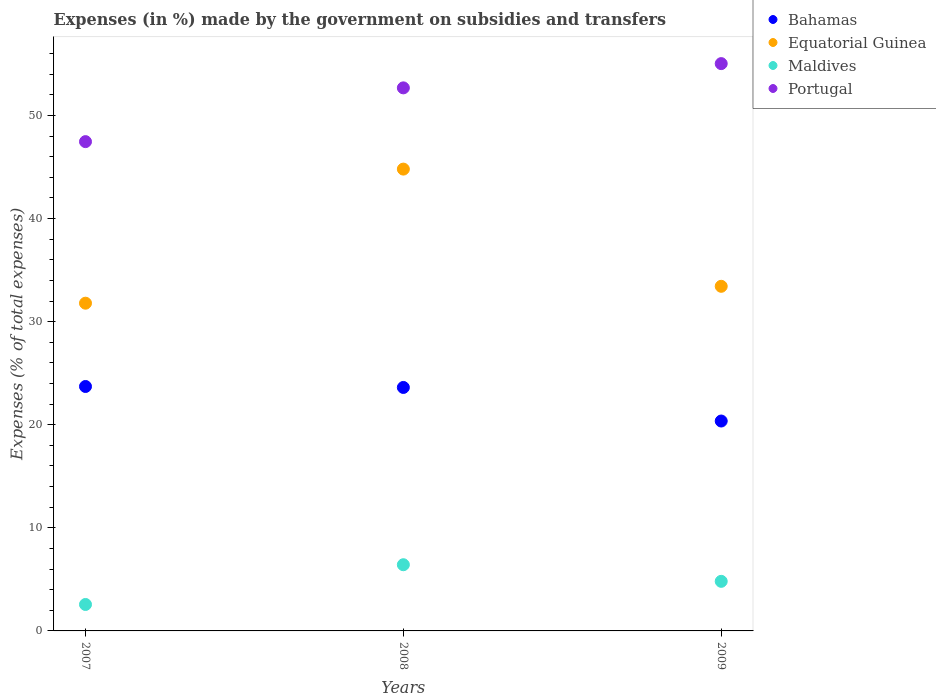What is the percentage of expenses made by the government on subsidies and transfers in Portugal in 2007?
Your answer should be compact. 47.46. Across all years, what is the maximum percentage of expenses made by the government on subsidies and transfers in Equatorial Guinea?
Offer a terse response. 44.8. Across all years, what is the minimum percentage of expenses made by the government on subsidies and transfers in Equatorial Guinea?
Your response must be concise. 31.79. In which year was the percentage of expenses made by the government on subsidies and transfers in Portugal minimum?
Make the answer very short. 2007. What is the total percentage of expenses made by the government on subsidies and transfers in Portugal in the graph?
Provide a succinct answer. 155.17. What is the difference between the percentage of expenses made by the government on subsidies and transfers in Bahamas in 2007 and that in 2009?
Your answer should be very brief. 3.35. What is the difference between the percentage of expenses made by the government on subsidies and transfers in Bahamas in 2008 and the percentage of expenses made by the government on subsidies and transfers in Equatorial Guinea in 2009?
Make the answer very short. -9.81. What is the average percentage of expenses made by the government on subsidies and transfers in Bahamas per year?
Offer a very short reply. 22.56. In the year 2007, what is the difference between the percentage of expenses made by the government on subsidies and transfers in Portugal and percentage of expenses made by the government on subsidies and transfers in Equatorial Guinea?
Give a very brief answer. 15.67. In how many years, is the percentage of expenses made by the government on subsidies and transfers in Maldives greater than 6 %?
Keep it short and to the point. 1. What is the ratio of the percentage of expenses made by the government on subsidies and transfers in Equatorial Guinea in 2007 to that in 2008?
Your response must be concise. 0.71. Is the percentage of expenses made by the government on subsidies and transfers in Bahamas in 2007 less than that in 2009?
Provide a succinct answer. No. What is the difference between the highest and the second highest percentage of expenses made by the government on subsidies and transfers in Maldives?
Make the answer very short. 1.61. What is the difference between the highest and the lowest percentage of expenses made by the government on subsidies and transfers in Equatorial Guinea?
Give a very brief answer. 13.01. Is it the case that in every year, the sum of the percentage of expenses made by the government on subsidies and transfers in Equatorial Guinea and percentage of expenses made by the government on subsidies and transfers in Bahamas  is greater than the sum of percentage of expenses made by the government on subsidies and transfers in Maldives and percentage of expenses made by the government on subsidies and transfers in Portugal?
Provide a succinct answer. No. Does the percentage of expenses made by the government on subsidies and transfers in Equatorial Guinea monotonically increase over the years?
Keep it short and to the point. No. Is the percentage of expenses made by the government on subsidies and transfers in Equatorial Guinea strictly less than the percentage of expenses made by the government on subsidies and transfers in Maldives over the years?
Ensure brevity in your answer.  No. How many dotlines are there?
Make the answer very short. 4. What is the difference between two consecutive major ticks on the Y-axis?
Give a very brief answer. 10. Are the values on the major ticks of Y-axis written in scientific E-notation?
Give a very brief answer. No. What is the title of the graph?
Provide a succinct answer. Expenses (in %) made by the government on subsidies and transfers. Does "Congo (Democratic)" appear as one of the legend labels in the graph?
Your answer should be very brief. No. What is the label or title of the Y-axis?
Give a very brief answer. Expenses (% of total expenses). What is the Expenses (% of total expenses) of Bahamas in 2007?
Make the answer very short. 23.71. What is the Expenses (% of total expenses) of Equatorial Guinea in 2007?
Provide a short and direct response. 31.79. What is the Expenses (% of total expenses) in Maldives in 2007?
Provide a short and direct response. 2.57. What is the Expenses (% of total expenses) of Portugal in 2007?
Provide a succinct answer. 47.46. What is the Expenses (% of total expenses) in Bahamas in 2008?
Offer a very short reply. 23.62. What is the Expenses (% of total expenses) in Equatorial Guinea in 2008?
Make the answer very short. 44.8. What is the Expenses (% of total expenses) in Maldives in 2008?
Your answer should be compact. 6.42. What is the Expenses (% of total expenses) of Portugal in 2008?
Your answer should be very brief. 52.68. What is the Expenses (% of total expenses) of Bahamas in 2009?
Your response must be concise. 20.36. What is the Expenses (% of total expenses) in Equatorial Guinea in 2009?
Your response must be concise. 33.43. What is the Expenses (% of total expenses) in Maldives in 2009?
Your answer should be very brief. 4.81. What is the Expenses (% of total expenses) of Portugal in 2009?
Offer a terse response. 55.03. Across all years, what is the maximum Expenses (% of total expenses) of Bahamas?
Make the answer very short. 23.71. Across all years, what is the maximum Expenses (% of total expenses) in Equatorial Guinea?
Offer a very short reply. 44.8. Across all years, what is the maximum Expenses (% of total expenses) in Maldives?
Your response must be concise. 6.42. Across all years, what is the maximum Expenses (% of total expenses) in Portugal?
Offer a terse response. 55.03. Across all years, what is the minimum Expenses (% of total expenses) of Bahamas?
Provide a short and direct response. 20.36. Across all years, what is the minimum Expenses (% of total expenses) in Equatorial Guinea?
Provide a succinct answer. 31.79. Across all years, what is the minimum Expenses (% of total expenses) of Maldives?
Provide a short and direct response. 2.57. Across all years, what is the minimum Expenses (% of total expenses) in Portugal?
Provide a short and direct response. 47.46. What is the total Expenses (% of total expenses) in Bahamas in the graph?
Your response must be concise. 67.69. What is the total Expenses (% of total expenses) in Equatorial Guinea in the graph?
Keep it short and to the point. 110.01. What is the total Expenses (% of total expenses) of Maldives in the graph?
Your answer should be very brief. 13.8. What is the total Expenses (% of total expenses) in Portugal in the graph?
Provide a succinct answer. 155.17. What is the difference between the Expenses (% of total expenses) in Bahamas in 2007 and that in 2008?
Make the answer very short. 0.09. What is the difference between the Expenses (% of total expenses) of Equatorial Guinea in 2007 and that in 2008?
Your answer should be compact. -13.01. What is the difference between the Expenses (% of total expenses) of Maldives in 2007 and that in 2008?
Keep it short and to the point. -3.86. What is the difference between the Expenses (% of total expenses) of Portugal in 2007 and that in 2008?
Keep it short and to the point. -5.22. What is the difference between the Expenses (% of total expenses) of Bahamas in 2007 and that in 2009?
Make the answer very short. 3.35. What is the difference between the Expenses (% of total expenses) in Equatorial Guinea in 2007 and that in 2009?
Offer a terse response. -1.64. What is the difference between the Expenses (% of total expenses) in Maldives in 2007 and that in 2009?
Ensure brevity in your answer.  -2.24. What is the difference between the Expenses (% of total expenses) of Portugal in 2007 and that in 2009?
Offer a terse response. -7.57. What is the difference between the Expenses (% of total expenses) of Bahamas in 2008 and that in 2009?
Provide a succinct answer. 3.26. What is the difference between the Expenses (% of total expenses) in Equatorial Guinea in 2008 and that in 2009?
Ensure brevity in your answer.  11.37. What is the difference between the Expenses (% of total expenses) in Maldives in 2008 and that in 2009?
Your answer should be very brief. 1.61. What is the difference between the Expenses (% of total expenses) in Portugal in 2008 and that in 2009?
Offer a terse response. -2.35. What is the difference between the Expenses (% of total expenses) of Bahamas in 2007 and the Expenses (% of total expenses) of Equatorial Guinea in 2008?
Provide a short and direct response. -21.09. What is the difference between the Expenses (% of total expenses) of Bahamas in 2007 and the Expenses (% of total expenses) of Maldives in 2008?
Your response must be concise. 17.29. What is the difference between the Expenses (% of total expenses) in Bahamas in 2007 and the Expenses (% of total expenses) in Portugal in 2008?
Your answer should be compact. -28.97. What is the difference between the Expenses (% of total expenses) in Equatorial Guinea in 2007 and the Expenses (% of total expenses) in Maldives in 2008?
Keep it short and to the point. 25.37. What is the difference between the Expenses (% of total expenses) in Equatorial Guinea in 2007 and the Expenses (% of total expenses) in Portugal in 2008?
Ensure brevity in your answer.  -20.89. What is the difference between the Expenses (% of total expenses) in Maldives in 2007 and the Expenses (% of total expenses) in Portugal in 2008?
Your answer should be very brief. -50.11. What is the difference between the Expenses (% of total expenses) in Bahamas in 2007 and the Expenses (% of total expenses) in Equatorial Guinea in 2009?
Offer a very short reply. -9.72. What is the difference between the Expenses (% of total expenses) in Bahamas in 2007 and the Expenses (% of total expenses) in Maldives in 2009?
Offer a terse response. 18.9. What is the difference between the Expenses (% of total expenses) in Bahamas in 2007 and the Expenses (% of total expenses) in Portugal in 2009?
Make the answer very short. -31.32. What is the difference between the Expenses (% of total expenses) in Equatorial Guinea in 2007 and the Expenses (% of total expenses) in Maldives in 2009?
Your response must be concise. 26.98. What is the difference between the Expenses (% of total expenses) in Equatorial Guinea in 2007 and the Expenses (% of total expenses) in Portugal in 2009?
Your response must be concise. -23.24. What is the difference between the Expenses (% of total expenses) in Maldives in 2007 and the Expenses (% of total expenses) in Portugal in 2009?
Provide a succinct answer. -52.46. What is the difference between the Expenses (% of total expenses) in Bahamas in 2008 and the Expenses (% of total expenses) in Equatorial Guinea in 2009?
Ensure brevity in your answer.  -9.81. What is the difference between the Expenses (% of total expenses) of Bahamas in 2008 and the Expenses (% of total expenses) of Maldives in 2009?
Your response must be concise. 18.81. What is the difference between the Expenses (% of total expenses) in Bahamas in 2008 and the Expenses (% of total expenses) in Portugal in 2009?
Ensure brevity in your answer.  -31.41. What is the difference between the Expenses (% of total expenses) in Equatorial Guinea in 2008 and the Expenses (% of total expenses) in Maldives in 2009?
Your response must be concise. 39.99. What is the difference between the Expenses (% of total expenses) of Equatorial Guinea in 2008 and the Expenses (% of total expenses) of Portugal in 2009?
Keep it short and to the point. -10.23. What is the difference between the Expenses (% of total expenses) in Maldives in 2008 and the Expenses (% of total expenses) in Portugal in 2009?
Offer a very short reply. -48.61. What is the average Expenses (% of total expenses) in Bahamas per year?
Your response must be concise. 22.56. What is the average Expenses (% of total expenses) of Equatorial Guinea per year?
Provide a succinct answer. 36.67. What is the average Expenses (% of total expenses) in Maldives per year?
Offer a terse response. 4.6. What is the average Expenses (% of total expenses) in Portugal per year?
Your answer should be very brief. 51.72. In the year 2007, what is the difference between the Expenses (% of total expenses) of Bahamas and Expenses (% of total expenses) of Equatorial Guinea?
Offer a very short reply. -8.08. In the year 2007, what is the difference between the Expenses (% of total expenses) of Bahamas and Expenses (% of total expenses) of Maldives?
Provide a short and direct response. 21.15. In the year 2007, what is the difference between the Expenses (% of total expenses) in Bahamas and Expenses (% of total expenses) in Portugal?
Provide a succinct answer. -23.75. In the year 2007, what is the difference between the Expenses (% of total expenses) in Equatorial Guinea and Expenses (% of total expenses) in Maldives?
Provide a short and direct response. 29.22. In the year 2007, what is the difference between the Expenses (% of total expenses) of Equatorial Guinea and Expenses (% of total expenses) of Portugal?
Ensure brevity in your answer.  -15.67. In the year 2007, what is the difference between the Expenses (% of total expenses) of Maldives and Expenses (% of total expenses) of Portugal?
Offer a terse response. -44.9. In the year 2008, what is the difference between the Expenses (% of total expenses) of Bahamas and Expenses (% of total expenses) of Equatorial Guinea?
Your answer should be very brief. -21.18. In the year 2008, what is the difference between the Expenses (% of total expenses) of Bahamas and Expenses (% of total expenses) of Maldives?
Your answer should be compact. 17.2. In the year 2008, what is the difference between the Expenses (% of total expenses) in Bahamas and Expenses (% of total expenses) in Portugal?
Make the answer very short. -29.06. In the year 2008, what is the difference between the Expenses (% of total expenses) in Equatorial Guinea and Expenses (% of total expenses) in Maldives?
Ensure brevity in your answer.  38.38. In the year 2008, what is the difference between the Expenses (% of total expenses) in Equatorial Guinea and Expenses (% of total expenses) in Portugal?
Offer a terse response. -7.88. In the year 2008, what is the difference between the Expenses (% of total expenses) in Maldives and Expenses (% of total expenses) in Portugal?
Your answer should be compact. -46.26. In the year 2009, what is the difference between the Expenses (% of total expenses) of Bahamas and Expenses (% of total expenses) of Equatorial Guinea?
Make the answer very short. -13.07. In the year 2009, what is the difference between the Expenses (% of total expenses) of Bahamas and Expenses (% of total expenses) of Maldives?
Provide a succinct answer. 15.55. In the year 2009, what is the difference between the Expenses (% of total expenses) in Bahamas and Expenses (% of total expenses) in Portugal?
Your answer should be very brief. -34.67. In the year 2009, what is the difference between the Expenses (% of total expenses) of Equatorial Guinea and Expenses (% of total expenses) of Maldives?
Your response must be concise. 28.62. In the year 2009, what is the difference between the Expenses (% of total expenses) of Equatorial Guinea and Expenses (% of total expenses) of Portugal?
Keep it short and to the point. -21.6. In the year 2009, what is the difference between the Expenses (% of total expenses) of Maldives and Expenses (% of total expenses) of Portugal?
Keep it short and to the point. -50.22. What is the ratio of the Expenses (% of total expenses) of Equatorial Guinea in 2007 to that in 2008?
Your response must be concise. 0.71. What is the ratio of the Expenses (% of total expenses) in Maldives in 2007 to that in 2008?
Your answer should be compact. 0.4. What is the ratio of the Expenses (% of total expenses) in Portugal in 2007 to that in 2008?
Give a very brief answer. 0.9. What is the ratio of the Expenses (% of total expenses) in Bahamas in 2007 to that in 2009?
Offer a very short reply. 1.16. What is the ratio of the Expenses (% of total expenses) in Equatorial Guinea in 2007 to that in 2009?
Make the answer very short. 0.95. What is the ratio of the Expenses (% of total expenses) in Maldives in 2007 to that in 2009?
Ensure brevity in your answer.  0.53. What is the ratio of the Expenses (% of total expenses) of Portugal in 2007 to that in 2009?
Make the answer very short. 0.86. What is the ratio of the Expenses (% of total expenses) in Bahamas in 2008 to that in 2009?
Make the answer very short. 1.16. What is the ratio of the Expenses (% of total expenses) of Equatorial Guinea in 2008 to that in 2009?
Your response must be concise. 1.34. What is the ratio of the Expenses (% of total expenses) in Maldives in 2008 to that in 2009?
Provide a succinct answer. 1.33. What is the ratio of the Expenses (% of total expenses) of Portugal in 2008 to that in 2009?
Your response must be concise. 0.96. What is the difference between the highest and the second highest Expenses (% of total expenses) of Bahamas?
Your answer should be very brief. 0.09. What is the difference between the highest and the second highest Expenses (% of total expenses) in Equatorial Guinea?
Your answer should be compact. 11.37. What is the difference between the highest and the second highest Expenses (% of total expenses) of Maldives?
Keep it short and to the point. 1.61. What is the difference between the highest and the second highest Expenses (% of total expenses) of Portugal?
Give a very brief answer. 2.35. What is the difference between the highest and the lowest Expenses (% of total expenses) in Bahamas?
Keep it short and to the point. 3.35. What is the difference between the highest and the lowest Expenses (% of total expenses) in Equatorial Guinea?
Keep it short and to the point. 13.01. What is the difference between the highest and the lowest Expenses (% of total expenses) in Maldives?
Offer a very short reply. 3.86. What is the difference between the highest and the lowest Expenses (% of total expenses) of Portugal?
Your answer should be very brief. 7.57. 